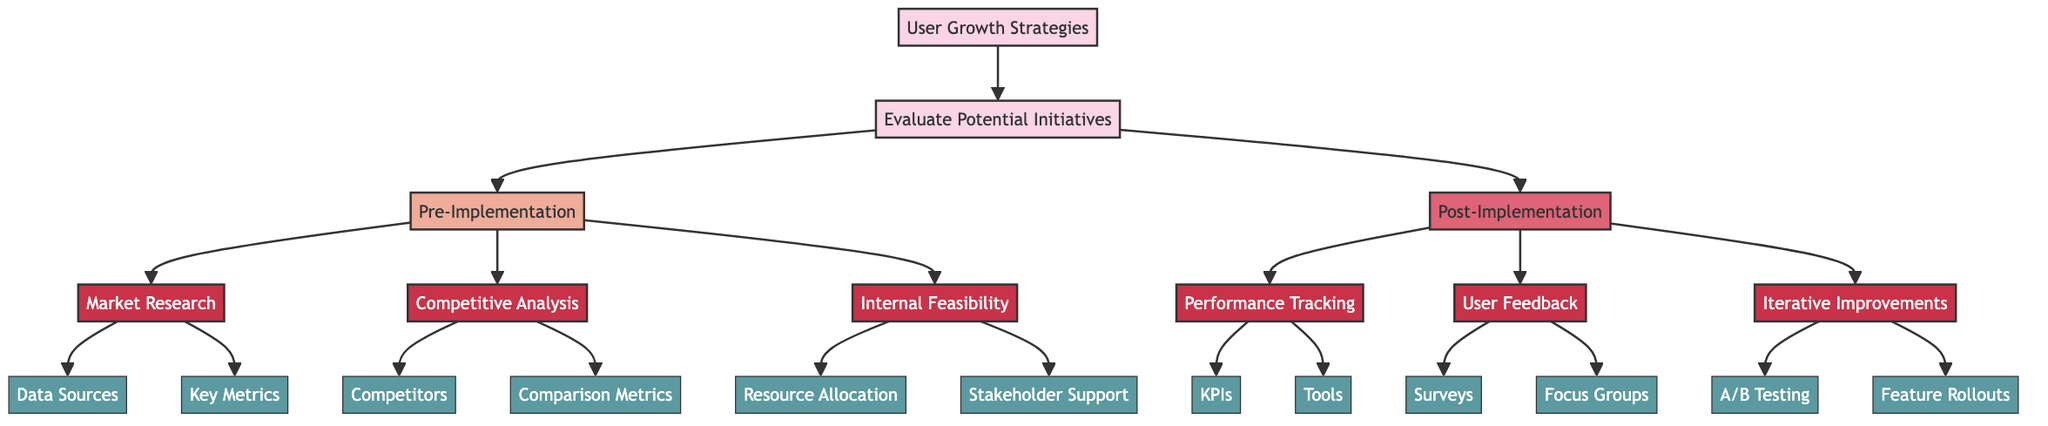What are the two main sections of the user growth strategies? The diagram clearly shows two main sections under the user growth strategies: Pre-Implementation and Post-Implementation. These sections categorize the strategies being evaluated in terms of their implementation phases.
Answer: Pre-Implementation and Post-Implementation How many potential initiatives are evaluated in the Pre-Implementation phase? In the Pre-Implementation section of the diagram, there are three potential initiatives listed: Market Research, Competitive Analysis, and Internal Feasibility, indicating that a total of three are evaluated before implementation.
Answer: Three Which tools are recommended for Performance Tracking? The diagram indicates that for Performance Tracking, three tools are suggested: Facebook Analytics, Tableau, and Google Analytics. Therefore, the answer will mention these specific tools used for tracking user performance post-implementation.
Answer: Facebook Analytics, Tableau, and Google Analytics What is one type of user feedback method listed in the Post-Implementation stage? The Post-Implementation stage lists two major methods for gathering user feedback: Surveys and Focus Groups. The question asks for one, therefore, any one of these methods can be an acceptable answer.
Answer: Surveys What key metrics are included in the Market Research section? The Market Research section outlines several key metrics to evaluate initiatives, specifically mentioning User Engagement Rate, Market Penetration, and User Demographics Analysis. The question typically requires listing these metrics that are essential in research before implementation.
Answer: User Engagement Rate, Market Penetration, User Demographics Analysis Which competitive analysis competitors are included? The Competitive Analysis section specifically mentions three competitors to consider in strategic evaluations: TikTok, Snapchat, and Twitter. Therefore, the answer should involve all these competitors listed for clear understanding.
Answer: TikTok, Snapchat, and Twitter How many subcategories are there in the Post-Implementation section? The Post-Implementation section presents three subcategories: Performance Tracking, User Feedback, and Iterative Improvements. Counting these subcategories will result in the desired answer to the question regarding its count.
Answer: Three What phase includes A/B Testing? The action of A/B Testing is explicitly noted as part of the Iterative Improvements subcategory, which falls under the Post-Implementation phase. Therefore, the question identifies where A/B Testing occurs in the overall strategy structure.
Answer: Post-Implementation 